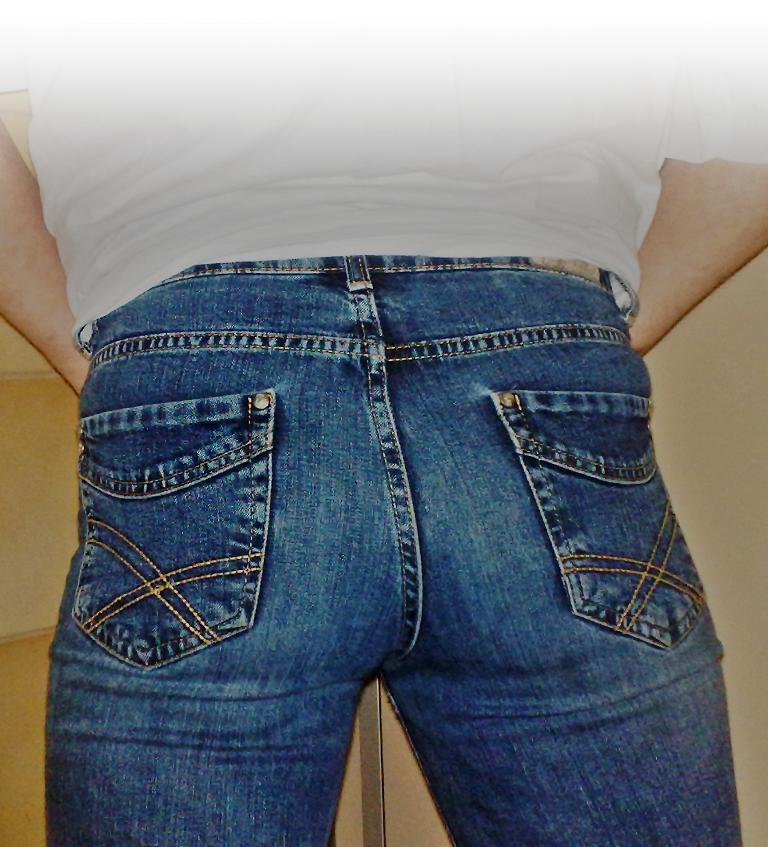What is present in the image? There is a person in the image. What type of clothing is the person wearing? The person is wearing jeans. How many lizards are crawling on the person's jeans in the image? There are no lizards present in the image. What type of army is depicted in the image? There is no army depicted in the image; it only features a person wearing jeans. 